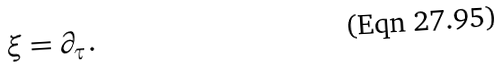Convert formula to latex. <formula><loc_0><loc_0><loc_500><loc_500>\xi = \partial _ { \tau } .</formula> 